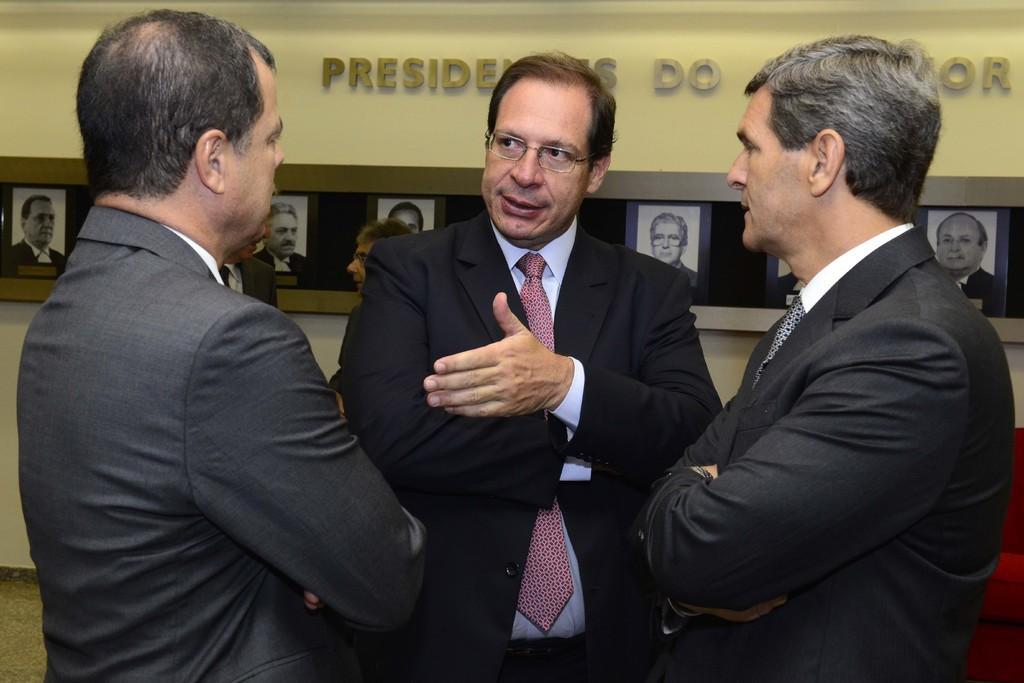Describe this image in one or two sentences. In this image we can see a group of men standing on the floor. On the backside we can see a sofa and a wall with some photo frames and some text on it. 